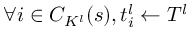<formula> <loc_0><loc_0><loc_500><loc_500>\forall i \in C _ { K ^ { l } } ( s ) , t _ { i } ^ { l } \gets T ^ { l }</formula> 